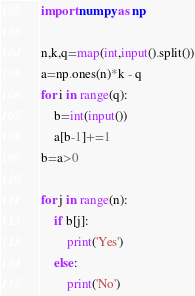Convert code to text. <code><loc_0><loc_0><loc_500><loc_500><_Python_>import numpy as np

n,k,q=map(int,input().split())
a=np.ones(n)*k - q
for i in range(q):
	b=int(input())
	a[b-1]+=1
b=a>0

for j in range(n):
	if b[j]:
		print('Yes')
	else:
		print('No')</code> 